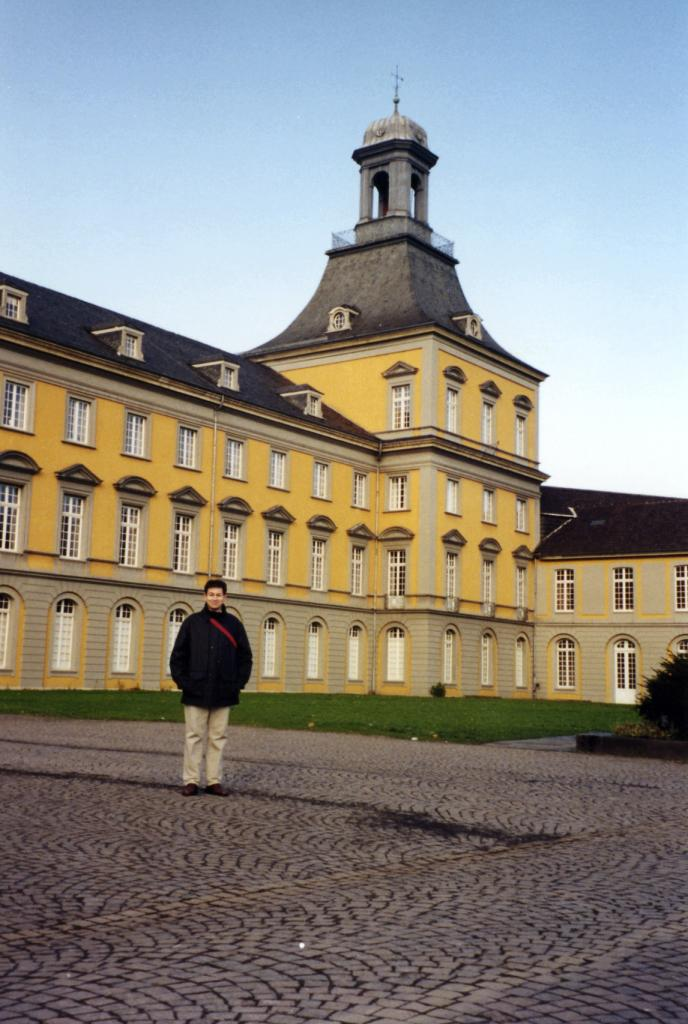Who is the main subject in the image? There is a person in the center of the image. Where is the person located? The person is on the road. What can be seen in the background of the image? There is a building and a tree in the background of the image. What is visible on the ground in the image? The ground is visible in the image. What is visible at the top of the image? The sky is visible at the top of the image. Can you see a plate of food next to the person in the image? There is no plate of food visible in the image. Is there any dirt visible on the person's clothes in the image? There is no dirt visible on the person's clothes in the image. 